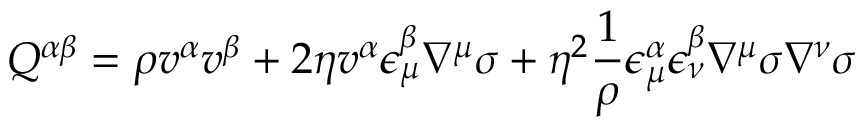Convert formula to latex. <formula><loc_0><loc_0><loc_500><loc_500>Q ^ { \alpha \beta } = \rho v ^ { \alpha } v ^ { \beta } + 2 \eta v ^ { \alpha } \epsilon _ { \mu } ^ { \beta } \nabla ^ { \mu } \sigma + \eta ^ { 2 } \frac { 1 } { \rho } \epsilon _ { \mu } ^ { \alpha } \epsilon _ { \nu } ^ { \beta } \nabla ^ { \mu } \sigma \nabla ^ { \nu } \sigma</formula> 